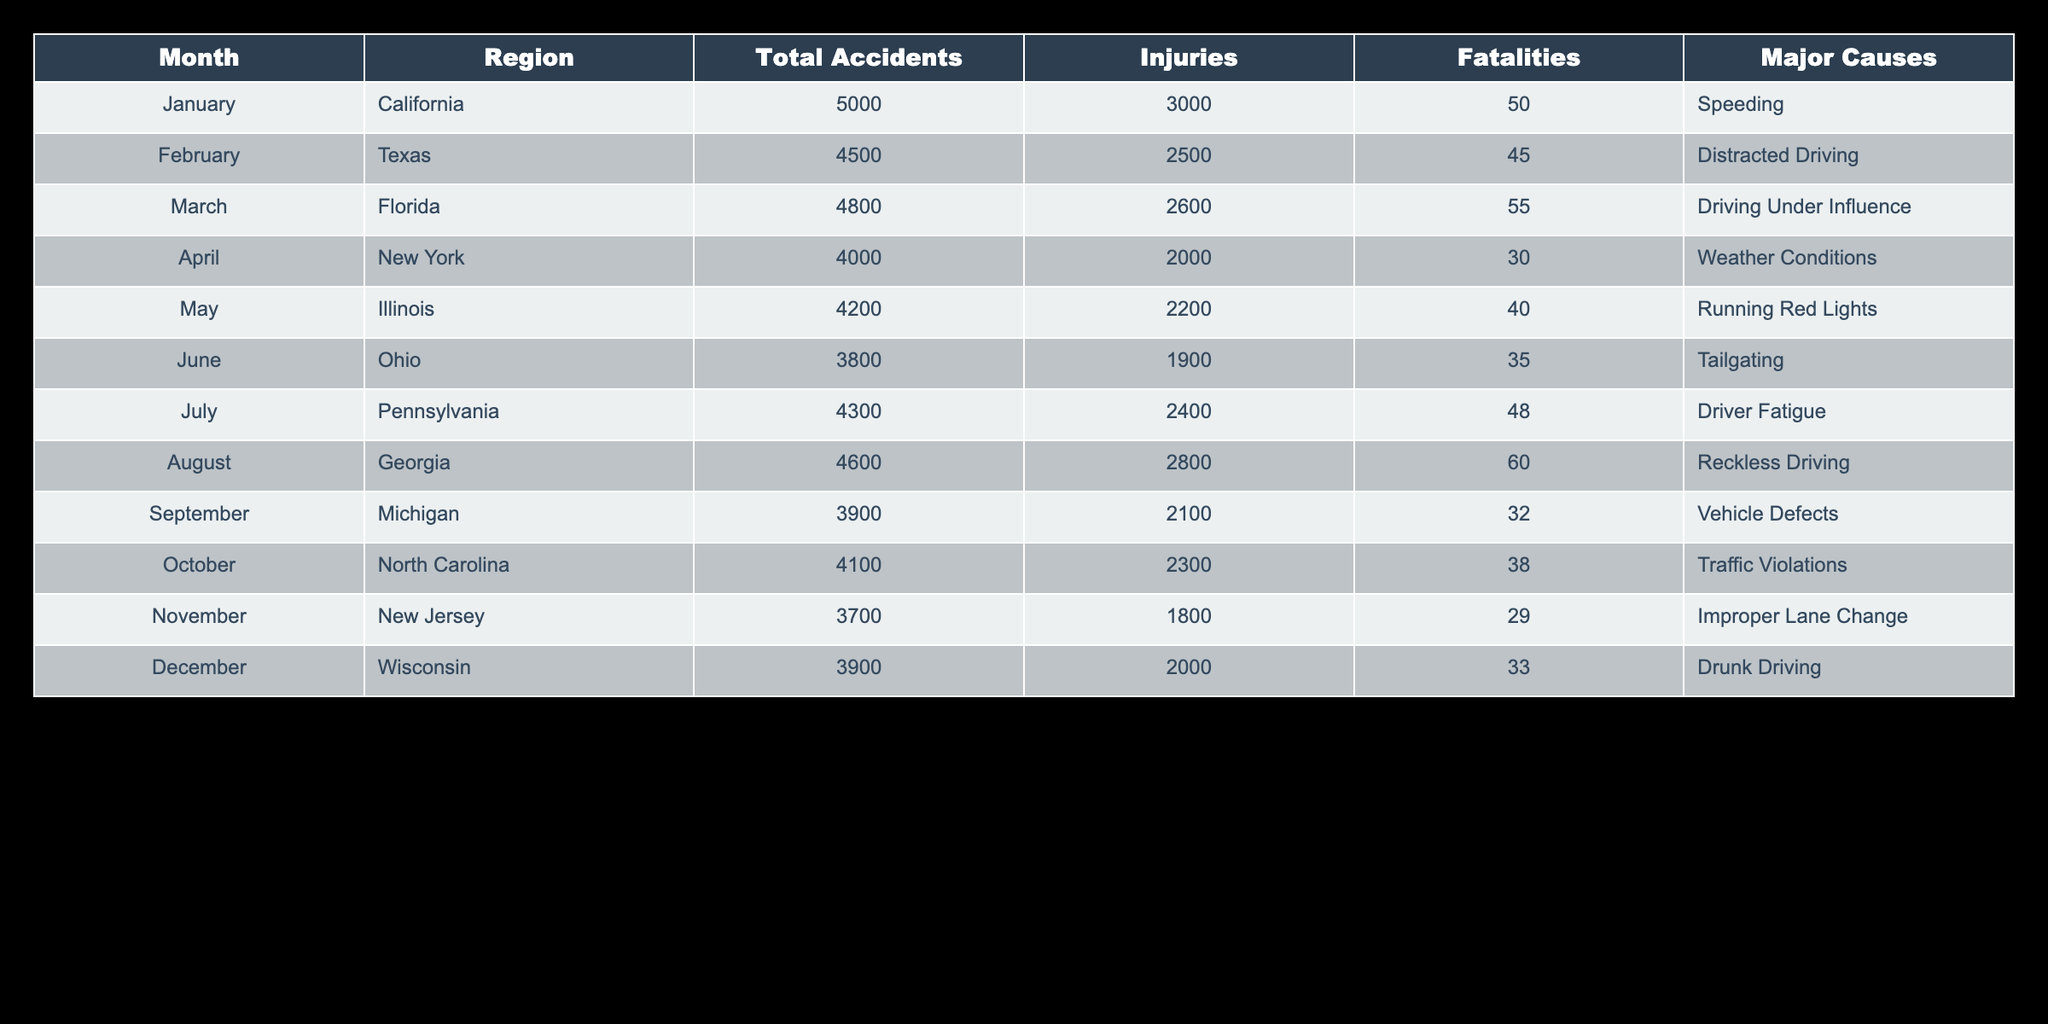What's the total number of fatalities reported for the region of Florida? In the table, we look for the row corresponding to Florida, which shows 55 fatalities listed under the Fatalities column.
Answer: 55 Which month had the highest number of total accidents? The month with the highest total accidents can be found by comparing the Total Accidents column. January has 5000 accidents, which is higher than any other month listed.
Answer: January What is the average number of injuries across all regions? To find the average, we add the number of injuries for all regions: 3000 + 2500 + 2600 + 2000 + 2200 + 1900 + 2400 + 2800 + 2100 + 2300 + 1800 + 2000 = 28,600. There are 12 months, so the average is 28600 / 12 = 2383.33.
Answer: 2383.33 Did any region report more than 60 fatalities in a single month? By checking the Fatalities column for all regions, we see that the maximum is 60 in August (Georgia). Therefore, there are no regions reporting more than 60 fatalities.
Answer: No How many accidents were attributed to speeding, and which month did that occur? Referring to the Major Causes column, it states that speeding was the cause of the accidents in January. The Total Accidents for January is 5000.
Answer: 5000 accidents in January What is the difference in the number of fatalities between the regions of California and Texas? The table shows 50 fatalities in California and 45 in Texas. The difference is calculated as 50 - 45 = 5.
Answer: 5 What was the total number of injuries in the regions New York and Pennsylvania combined? For New York, there are 2000 injuries and for Pennsylvania, 2400 injuries. Adding these gives us 2000 + 2400 = 4400.
Answer: 4400 Which major cause of accidents had the most occurrences, based on the table? Scanning the table for Major Causes and their corresponding months, Reckless Driving appears once in August, as does Speeding in January, while the causes occur with equal frequency, revealing no singularly dominating cause as they all occur only once each month.
Answer: No dominate cause In which region did Drunk Driving cause the most fatalities? Checking the Major Causes column, Drunk Driving leads to 33 fatalities in Wisconsin, as it is the only listed instance of Drunk Driving in the table.
Answer: Wisconsin with 33 fatalities 